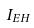<formula> <loc_0><loc_0><loc_500><loc_500>I _ { E H }</formula> 